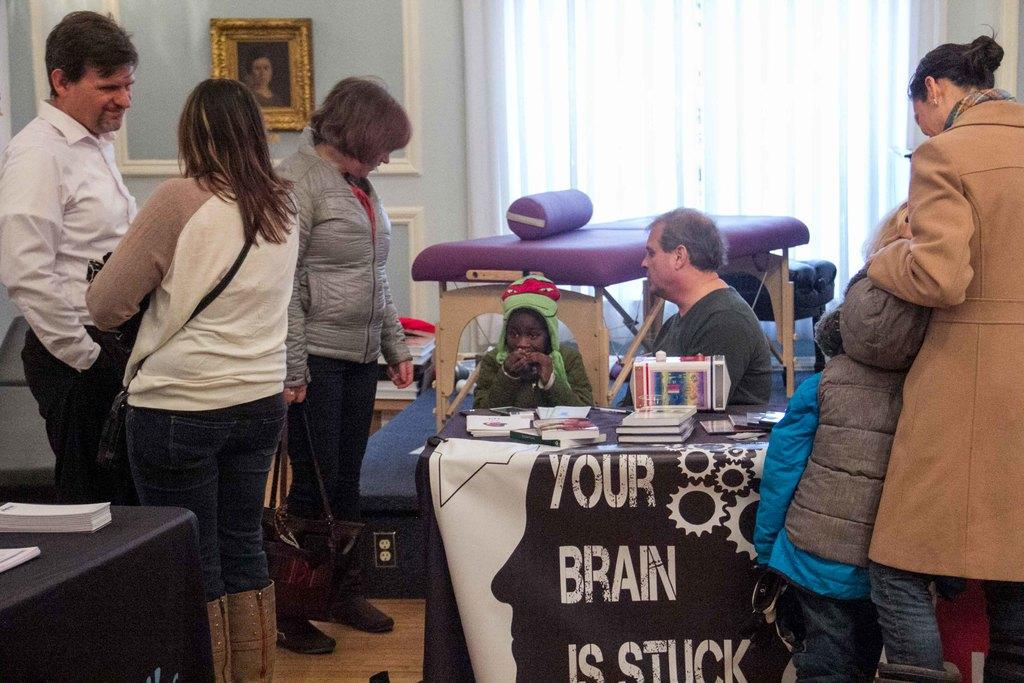How many people are in the image? There are persons standing and sitting in the image, making a total of four people. What are the people in the image doing? The people are standing and sitting, but their specific activities are not clear from the image. What can be seen on the tables in the image? There are books and other things on the tables. What is visible in the background of the image? There is a wall, a frame, and a curtain in the background of the image. What type of cord is being used to prepare breakfast in the image? There is no mention of breakfast or a cord in the image; it only shows people, tables, books, and background elements. 